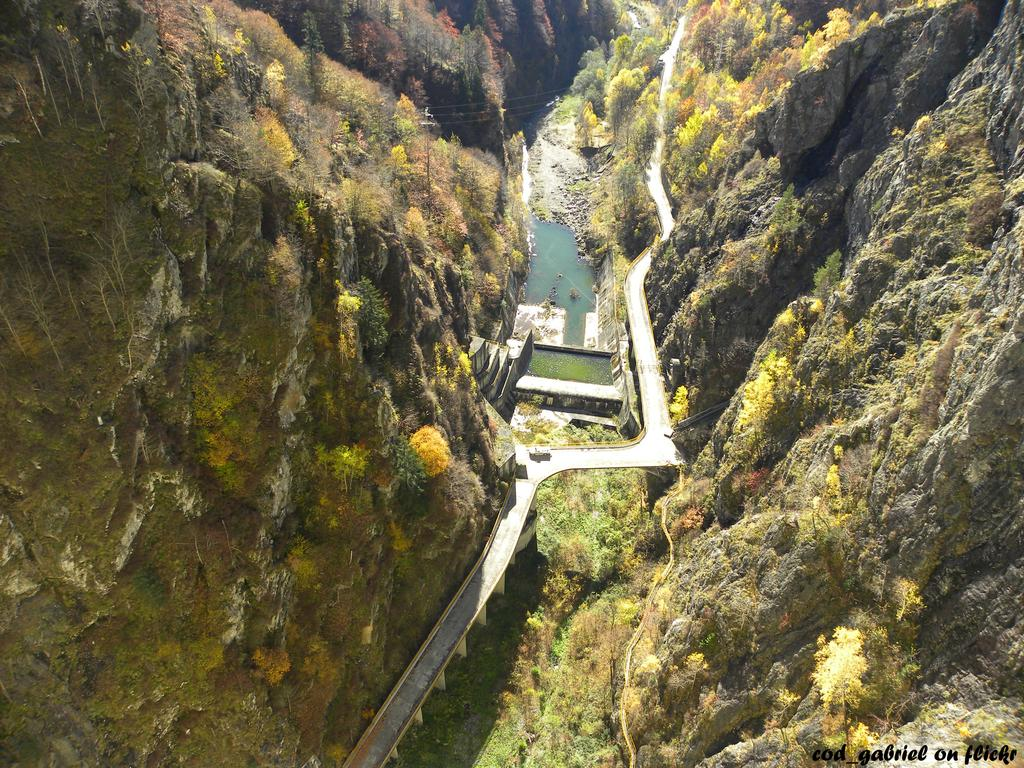What type of natural elements can be seen on both sides of the image? There are rocks on both the right and left sides of the image. What other natural elements are present in the image? There are plants and water visible in the image. Is there any man-made structure in the image? Yes, there is a path in the image. Can you describe the maid's outfit in the image? There is no maid present in the image. What type of club is visible in the image? There is no club present in the image. 